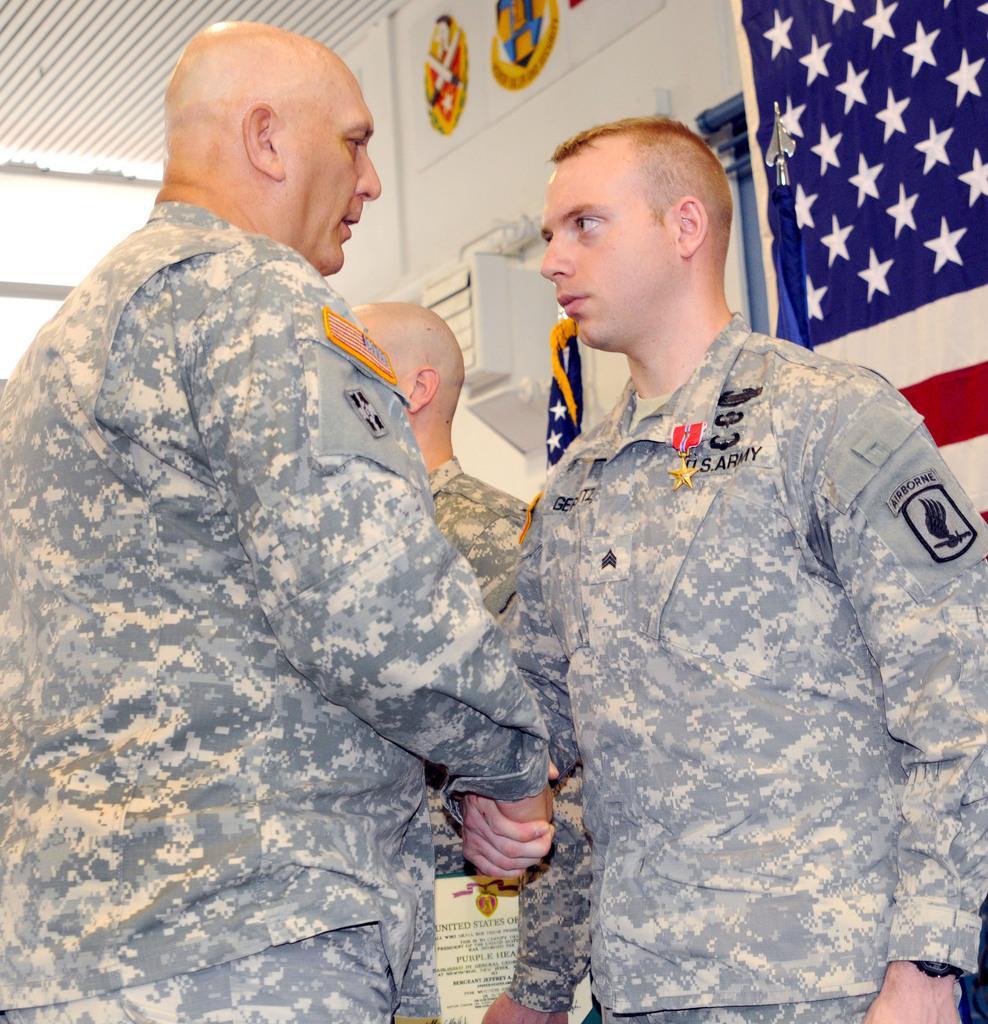How would you summarize this image in a sentence or two? In this image I can see two person wearing military uniform are standing and in the background I can see another person wearing military uniform is standing and holding a paper in his hand. I can see the wall, the flag, the ceiling and the sky. 